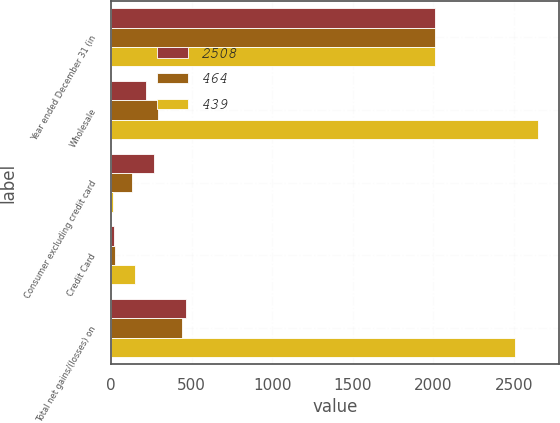<chart> <loc_0><loc_0><loc_500><loc_500><stacked_bar_chart><ecel><fcel>Year ended December 31 (in<fcel>Wholesale<fcel>Consumer excluding credit card<fcel>Credit Card<fcel>Total net gains/(losses) on<nl><fcel>2508<fcel>2010<fcel>215<fcel>265<fcel>16<fcel>464<nl><fcel>464<fcel>2009<fcel>291<fcel>127<fcel>21<fcel>439<nl><fcel>439<fcel>2008<fcel>2647<fcel>11<fcel>150<fcel>2508<nl></chart> 